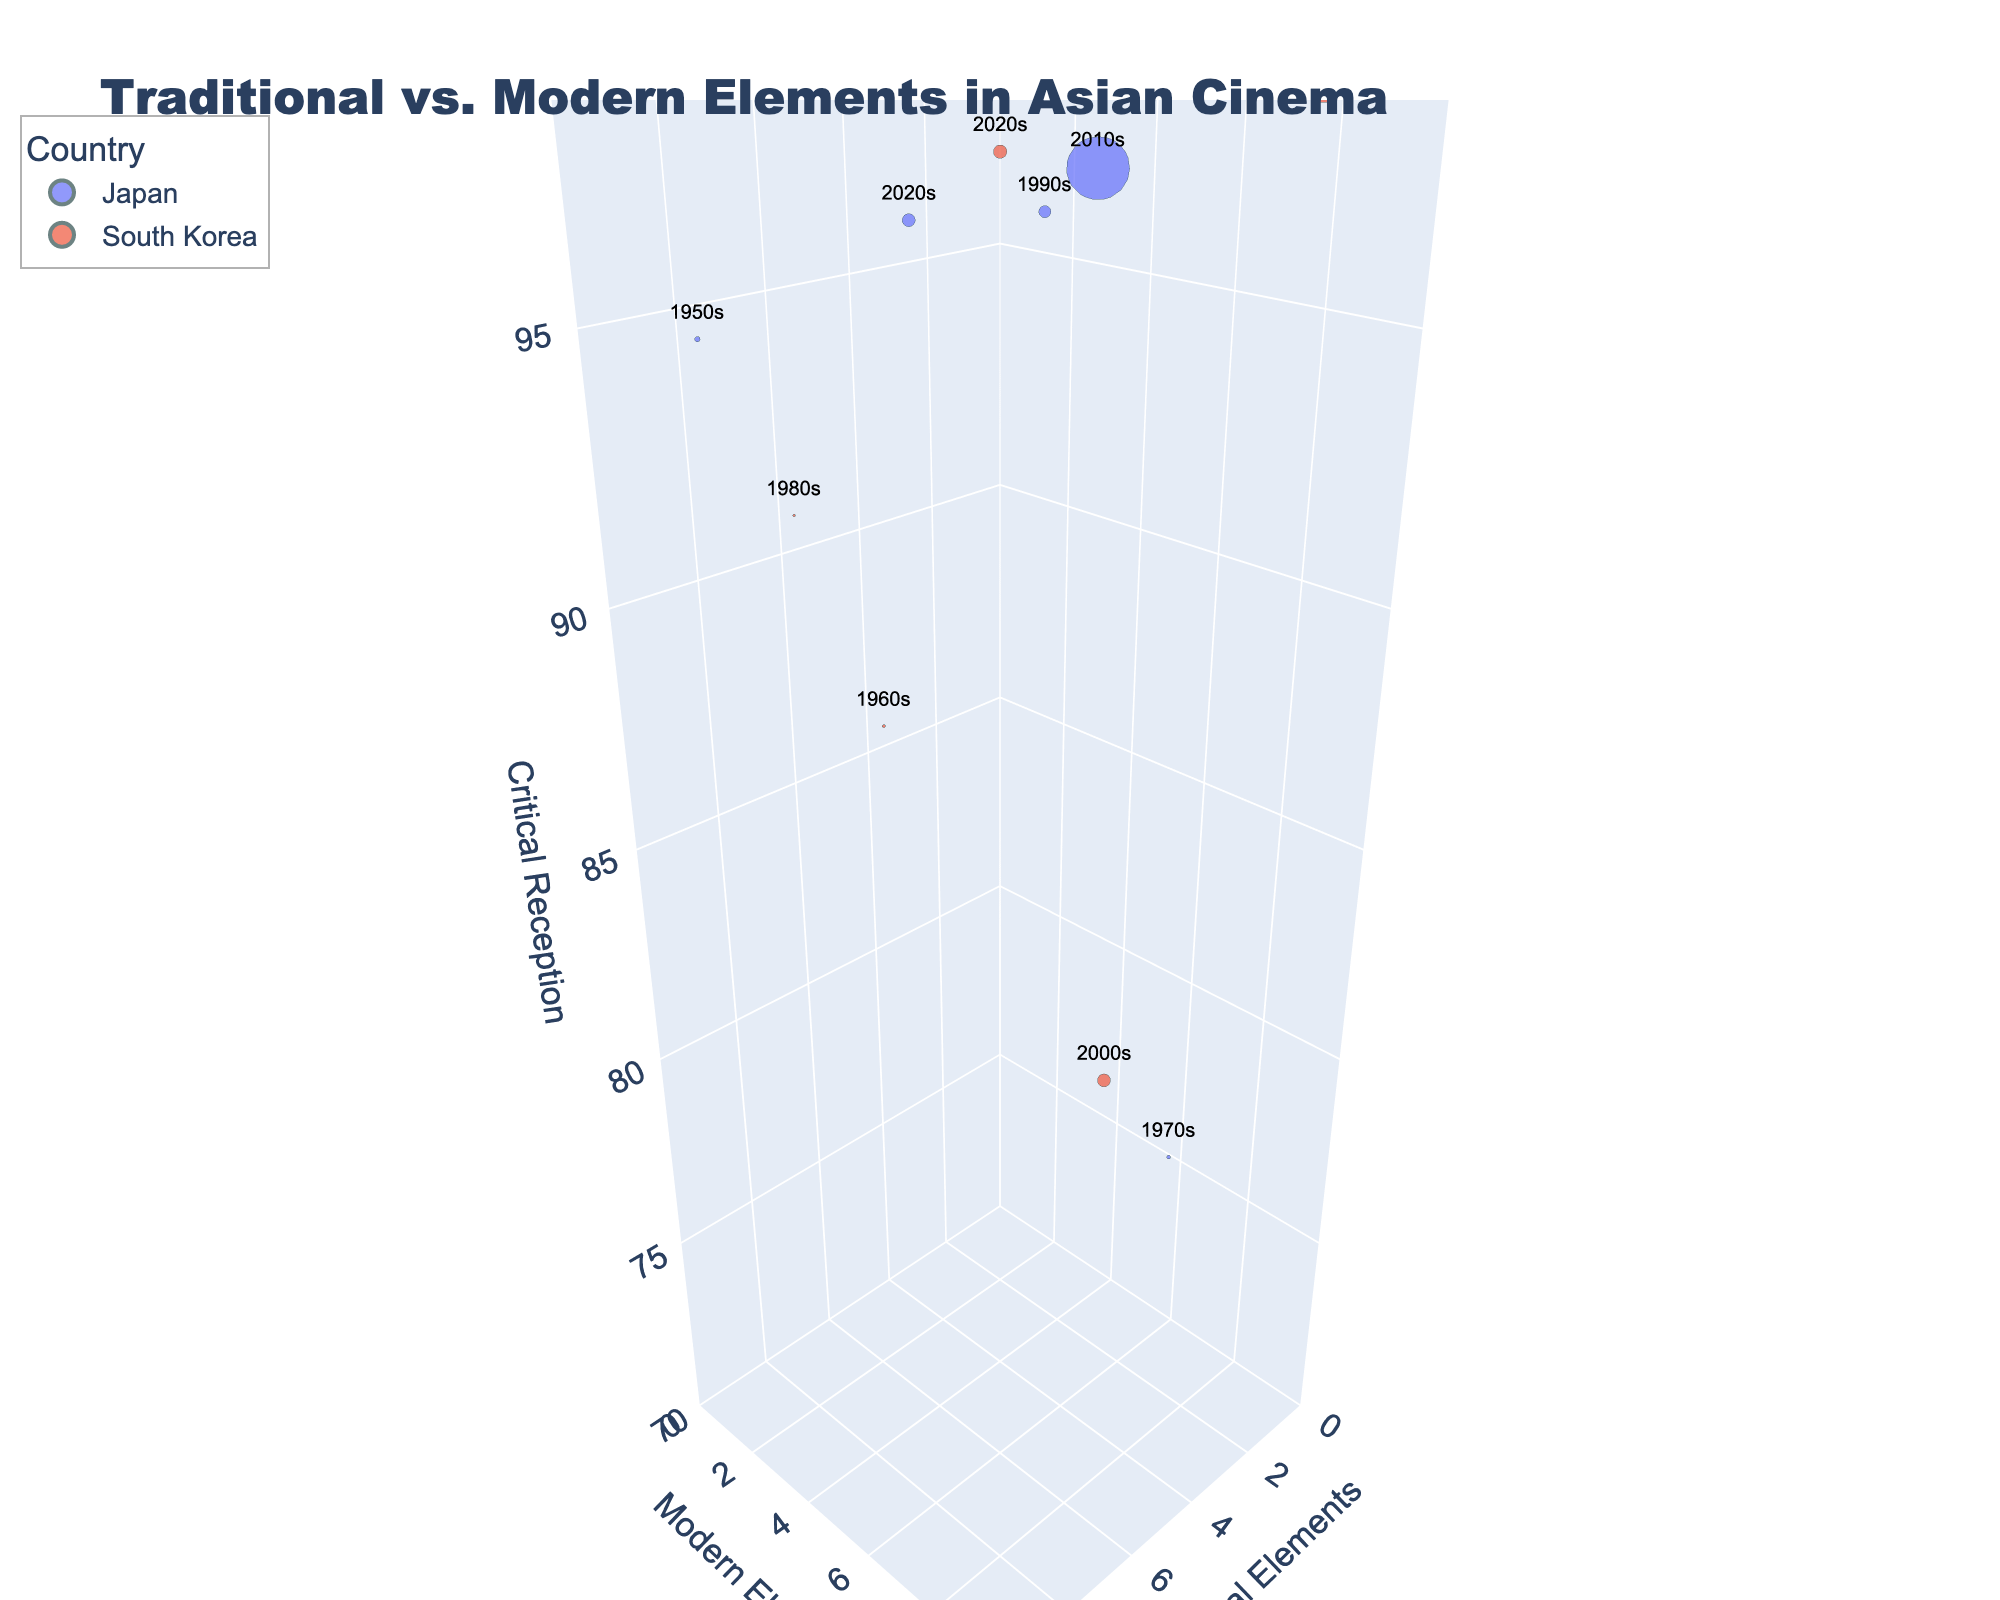What is the title of the chart? The title is written at the top of the chart in a large font. It reads: "Traditional vs. Modern Elements in Asian Cinema".
Answer: Traditional vs. Modern Elements in Asian Cinema Which country has more data points in the 2010s? By observing the bubble chart scatter and checking the decade labels, Japan and South Korea both have two data points in the 2010s.
Answer: Both Japan and South Korea What is the critical reception range represented in the plot? By looking at the z-axis titled "Critical Reception," the range is shown from 70 to 100.
Answer: 70 to 100 Which film has the largest bubble size, and how big is its Box Office in Millions USD? The largest bubble represents "Your Name" from Japan in the 2010s, with a Box Office size of 358 million USD.
Answer: Your Name, 358 Million USD What is the difference in traditional elements between "Seven Samurai" and "Parasite"? "Seven Samurai" has 9 traditional elements, and "Parasite" has 2 traditional elements. The difference is calculated as 9 - 2 = 7.
Answer: 7 Which film has the highest critical reception and what is its value? "Parasite" has the highest critical reception, noted at the top of the z-axis scale with a value of 99.
Answer: Parasite, 99 Comparing "Oldboy" and "Ringu", which film has more modern elements and by how much? "Oldboy" has 7 modern elements while "Ringu" has 6. The difference is calculated as 7 - 6 = 1.
Answer: Oldboy, by 1 How many films feature 8 traditional elements? Observing the x-axis for traditional elements and identifying the relevant bubbles, there are two films: "Seven Samurai" and "Why Has Bodhi-Dharma Left for the East?".
Answer: 2 What is the average critical reception of South Korean films? Summing the critical reception values for South Korean films and dividing by the number of films: (88 + 92 + 80 + 99 + 98)/5 = 91.4.
Answer: 91.4 Which decade has the highest representation of modern elements overall? By evaluating the y-axis and counting modern element values, the 2010s show consistently high modern elements (8 for "Your Name" and 9 for "Parasite").
Answer: 2010s 